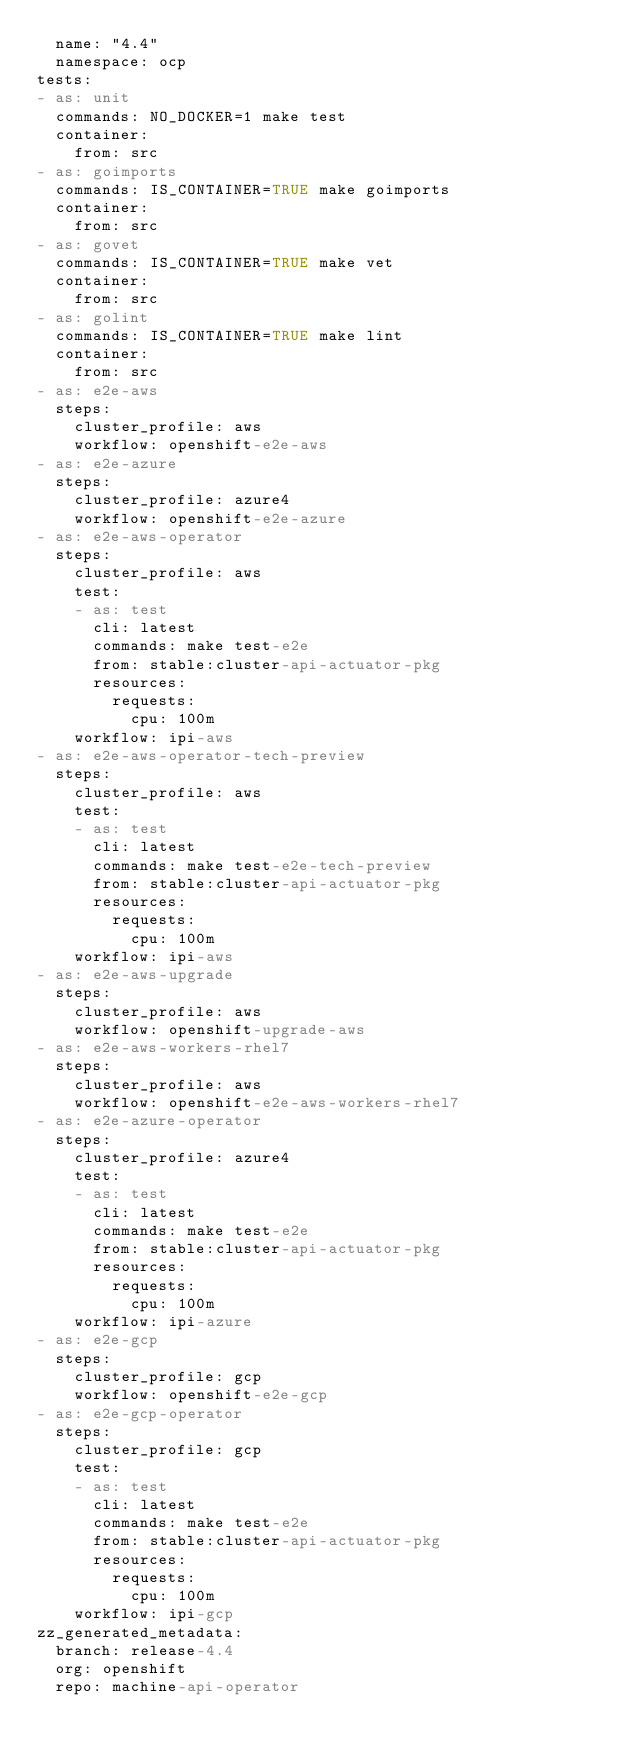<code> <loc_0><loc_0><loc_500><loc_500><_YAML_>  name: "4.4"
  namespace: ocp
tests:
- as: unit
  commands: NO_DOCKER=1 make test
  container:
    from: src
- as: goimports
  commands: IS_CONTAINER=TRUE make goimports
  container:
    from: src
- as: govet
  commands: IS_CONTAINER=TRUE make vet
  container:
    from: src
- as: golint
  commands: IS_CONTAINER=TRUE make lint
  container:
    from: src
- as: e2e-aws
  steps:
    cluster_profile: aws
    workflow: openshift-e2e-aws
- as: e2e-azure
  steps:
    cluster_profile: azure4
    workflow: openshift-e2e-azure
- as: e2e-aws-operator
  steps:
    cluster_profile: aws
    test:
    - as: test
      cli: latest
      commands: make test-e2e
      from: stable:cluster-api-actuator-pkg
      resources:
        requests:
          cpu: 100m
    workflow: ipi-aws
- as: e2e-aws-operator-tech-preview
  steps:
    cluster_profile: aws
    test:
    - as: test
      cli: latest
      commands: make test-e2e-tech-preview
      from: stable:cluster-api-actuator-pkg
      resources:
        requests:
          cpu: 100m
    workflow: ipi-aws
- as: e2e-aws-upgrade
  steps:
    cluster_profile: aws
    workflow: openshift-upgrade-aws
- as: e2e-aws-workers-rhel7
  steps:
    cluster_profile: aws
    workflow: openshift-e2e-aws-workers-rhel7
- as: e2e-azure-operator
  steps:
    cluster_profile: azure4
    test:
    - as: test
      cli: latest
      commands: make test-e2e
      from: stable:cluster-api-actuator-pkg
      resources:
        requests:
          cpu: 100m
    workflow: ipi-azure
- as: e2e-gcp
  steps:
    cluster_profile: gcp
    workflow: openshift-e2e-gcp
- as: e2e-gcp-operator
  steps:
    cluster_profile: gcp
    test:
    - as: test
      cli: latest
      commands: make test-e2e
      from: stable:cluster-api-actuator-pkg
      resources:
        requests:
          cpu: 100m
    workflow: ipi-gcp
zz_generated_metadata:
  branch: release-4.4
  org: openshift
  repo: machine-api-operator
</code> 